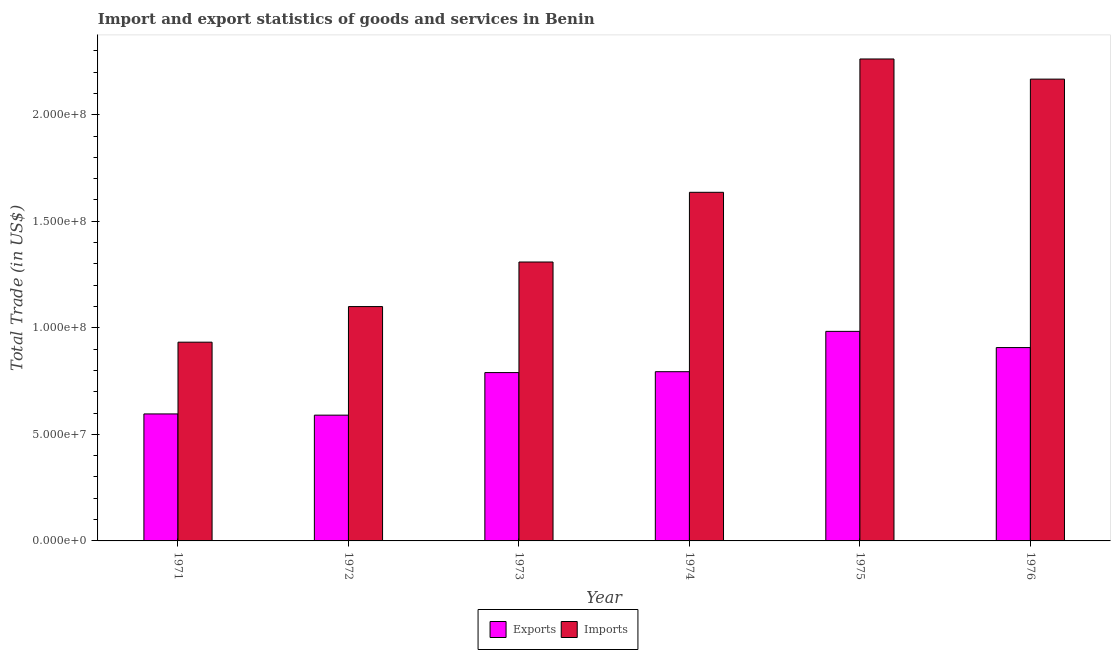How many groups of bars are there?
Your response must be concise. 6. Are the number of bars per tick equal to the number of legend labels?
Offer a terse response. Yes. Are the number of bars on each tick of the X-axis equal?
Keep it short and to the point. Yes. How many bars are there on the 6th tick from the right?
Offer a very short reply. 2. What is the label of the 6th group of bars from the left?
Your response must be concise. 1976. In how many cases, is the number of bars for a given year not equal to the number of legend labels?
Give a very brief answer. 0. What is the export of goods and services in 1974?
Your answer should be compact. 7.94e+07. Across all years, what is the maximum export of goods and services?
Give a very brief answer. 9.83e+07. Across all years, what is the minimum imports of goods and services?
Offer a very short reply. 9.33e+07. In which year was the export of goods and services maximum?
Offer a terse response. 1975. In which year was the imports of goods and services minimum?
Your answer should be compact. 1971. What is the total export of goods and services in the graph?
Your answer should be very brief. 4.66e+08. What is the difference between the imports of goods and services in 1975 and that in 1976?
Provide a succinct answer. 9.46e+06. What is the difference between the export of goods and services in 1975 and the imports of goods and services in 1974?
Give a very brief answer. 1.89e+07. What is the average imports of goods and services per year?
Provide a succinct answer. 1.57e+08. In the year 1973, what is the difference between the export of goods and services and imports of goods and services?
Give a very brief answer. 0. What is the ratio of the export of goods and services in 1971 to that in 1975?
Give a very brief answer. 0.61. Is the difference between the export of goods and services in 1972 and 1973 greater than the difference between the imports of goods and services in 1972 and 1973?
Make the answer very short. No. What is the difference between the highest and the second highest imports of goods and services?
Ensure brevity in your answer.  9.46e+06. What is the difference between the highest and the lowest imports of goods and services?
Offer a very short reply. 1.33e+08. In how many years, is the imports of goods and services greater than the average imports of goods and services taken over all years?
Offer a very short reply. 3. Is the sum of the export of goods and services in 1972 and 1975 greater than the maximum imports of goods and services across all years?
Make the answer very short. Yes. What does the 2nd bar from the left in 1971 represents?
Make the answer very short. Imports. What does the 1st bar from the right in 1976 represents?
Your answer should be very brief. Imports. What is the difference between two consecutive major ticks on the Y-axis?
Your answer should be very brief. 5.00e+07. Are the values on the major ticks of Y-axis written in scientific E-notation?
Provide a succinct answer. Yes. How are the legend labels stacked?
Keep it short and to the point. Horizontal. What is the title of the graph?
Your answer should be very brief. Import and export statistics of goods and services in Benin. Does "Formally registered" appear as one of the legend labels in the graph?
Give a very brief answer. No. What is the label or title of the Y-axis?
Make the answer very short. Total Trade (in US$). What is the Total Trade (in US$) of Exports in 1971?
Your answer should be compact. 5.96e+07. What is the Total Trade (in US$) of Imports in 1971?
Ensure brevity in your answer.  9.33e+07. What is the Total Trade (in US$) of Exports in 1972?
Ensure brevity in your answer.  5.90e+07. What is the Total Trade (in US$) in Imports in 1972?
Your response must be concise. 1.10e+08. What is the Total Trade (in US$) in Exports in 1973?
Your answer should be compact. 7.90e+07. What is the Total Trade (in US$) of Imports in 1973?
Provide a short and direct response. 1.31e+08. What is the Total Trade (in US$) of Exports in 1974?
Offer a terse response. 7.94e+07. What is the Total Trade (in US$) in Imports in 1974?
Offer a very short reply. 1.64e+08. What is the Total Trade (in US$) of Exports in 1975?
Offer a terse response. 9.83e+07. What is the Total Trade (in US$) of Imports in 1975?
Your answer should be compact. 2.26e+08. What is the Total Trade (in US$) of Exports in 1976?
Provide a succinct answer. 9.07e+07. What is the Total Trade (in US$) of Imports in 1976?
Your answer should be very brief. 2.17e+08. Across all years, what is the maximum Total Trade (in US$) in Exports?
Make the answer very short. 9.83e+07. Across all years, what is the maximum Total Trade (in US$) in Imports?
Make the answer very short. 2.26e+08. Across all years, what is the minimum Total Trade (in US$) of Exports?
Provide a short and direct response. 5.90e+07. Across all years, what is the minimum Total Trade (in US$) of Imports?
Make the answer very short. 9.33e+07. What is the total Total Trade (in US$) of Exports in the graph?
Your response must be concise. 4.66e+08. What is the total Total Trade (in US$) in Imports in the graph?
Your response must be concise. 9.41e+08. What is the difference between the Total Trade (in US$) in Exports in 1971 and that in 1972?
Your response must be concise. 5.72e+05. What is the difference between the Total Trade (in US$) of Imports in 1971 and that in 1972?
Your answer should be compact. -1.67e+07. What is the difference between the Total Trade (in US$) of Exports in 1971 and that in 1973?
Your response must be concise. -1.94e+07. What is the difference between the Total Trade (in US$) of Imports in 1971 and that in 1973?
Offer a very short reply. -3.76e+07. What is the difference between the Total Trade (in US$) in Exports in 1971 and that in 1974?
Your answer should be very brief. -1.98e+07. What is the difference between the Total Trade (in US$) in Imports in 1971 and that in 1974?
Your answer should be very brief. -7.03e+07. What is the difference between the Total Trade (in US$) of Exports in 1971 and that in 1975?
Make the answer very short. -3.87e+07. What is the difference between the Total Trade (in US$) in Imports in 1971 and that in 1975?
Provide a short and direct response. -1.33e+08. What is the difference between the Total Trade (in US$) in Exports in 1971 and that in 1976?
Provide a short and direct response. -3.11e+07. What is the difference between the Total Trade (in US$) of Imports in 1971 and that in 1976?
Your response must be concise. -1.23e+08. What is the difference between the Total Trade (in US$) in Exports in 1972 and that in 1973?
Provide a short and direct response. -2.00e+07. What is the difference between the Total Trade (in US$) of Imports in 1972 and that in 1973?
Offer a terse response. -2.09e+07. What is the difference between the Total Trade (in US$) of Exports in 1972 and that in 1974?
Offer a terse response. -2.04e+07. What is the difference between the Total Trade (in US$) in Imports in 1972 and that in 1974?
Ensure brevity in your answer.  -5.36e+07. What is the difference between the Total Trade (in US$) in Exports in 1972 and that in 1975?
Give a very brief answer. -3.93e+07. What is the difference between the Total Trade (in US$) of Imports in 1972 and that in 1975?
Ensure brevity in your answer.  -1.16e+08. What is the difference between the Total Trade (in US$) of Exports in 1972 and that in 1976?
Provide a short and direct response. -3.17e+07. What is the difference between the Total Trade (in US$) of Imports in 1972 and that in 1976?
Ensure brevity in your answer.  -1.07e+08. What is the difference between the Total Trade (in US$) in Exports in 1973 and that in 1974?
Give a very brief answer. -4.13e+05. What is the difference between the Total Trade (in US$) in Imports in 1973 and that in 1974?
Your answer should be very brief. -3.27e+07. What is the difference between the Total Trade (in US$) of Exports in 1973 and that in 1975?
Offer a terse response. -1.93e+07. What is the difference between the Total Trade (in US$) of Imports in 1973 and that in 1975?
Your answer should be very brief. -9.53e+07. What is the difference between the Total Trade (in US$) in Exports in 1973 and that in 1976?
Offer a very short reply. -1.17e+07. What is the difference between the Total Trade (in US$) in Imports in 1973 and that in 1976?
Provide a short and direct response. -8.58e+07. What is the difference between the Total Trade (in US$) of Exports in 1974 and that in 1975?
Your response must be concise. -1.89e+07. What is the difference between the Total Trade (in US$) of Imports in 1974 and that in 1975?
Ensure brevity in your answer.  -6.26e+07. What is the difference between the Total Trade (in US$) of Exports in 1974 and that in 1976?
Keep it short and to the point. -1.13e+07. What is the difference between the Total Trade (in US$) of Imports in 1974 and that in 1976?
Your answer should be compact. -5.31e+07. What is the difference between the Total Trade (in US$) in Exports in 1975 and that in 1976?
Your answer should be compact. 7.61e+06. What is the difference between the Total Trade (in US$) in Imports in 1975 and that in 1976?
Make the answer very short. 9.46e+06. What is the difference between the Total Trade (in US$) in Exports in 1971 and the Total Trade (in US$) in Imports in 1972?
Give a very brief answer. -5.04e+07. What is the difference between the Total Trade (in US$) of Exports in 1971 and the Total Trade (in US$) of Imports in 1973?
Offer a terse response. -7.13e+07. What is the difference between the Total Trade (in US$) in Exports in 1971 and the Total Trade (in US$) in Imports in 1974?
Provide a short and direct response. -1.04e+08. What is the difference between the Total Trade (in US$) in Exports in 1971 and the Total Trade (in US$) in Imports in 1975?
Make the answer very short. -1.67e+08. What is the difference between the Total Trade (in US$) in Exports in 1971 and the Total Trade (in US$) in Imports in 1976?
Give a very brief answer. -1.57e+08. What is the difference between the Total Trade (in US$) in Exports in 1972 and the Total Trade (in US$) in Imports in 1973?
Keep it short and to the point. -7.19e+07. What is the difference between the Total Trade (in US$) of Exports in 1972 and the Total Trade (in US$) of Imports in 1974?
Your answer should be very brief. -1.05e+08. What is the difference between the Total Trade (in US$) of Exports in 1972 and the Total Trade (in US$) of Imports in 1975?
Offer a terse response. -1.67e+08. What is the difference between the Total Trade (in US$) of Exports in 1972 and the Total Trade (in US$) of Imports in 1976?
Give a very brief answer. -1.58e+08. What is the difference between the Total Trade (in US$) of Exports in 1973 and the Total Trade (in US$) of Imports in 1974?
Ensure brevity in your answer.  -8.46e+07. What is the difference between the Total Trade (in US$) of Exports in 1973 and the Total Trade (in US$) of Imports in 1975?
Provide a succinct answer. -1.47e+08. What is the difference between the Total Trade (in US$) of Exports in 1973 and the Total Trade (in US$) of Imports in 1976?
Make the answer very short. -1.38e+08. What is the difference between the Total Trade (in US$) of Exports in 1974 and the Total Trade (in US$) of Imports in 1975?
Your answer should be compact. -1.47e+08. What is the difference between the Total Trade (in US$) of Exports in 1974 and the Total Trade (in US$) of Imports in 1976?
Provide a short and direct response. -1.37e+08. What is the difference between the Total Trade (in US$) of Exports in 1975 and the Total Trade (in US$) of Imports in 1976?
Your answer should be compact. -1.18e+08. What is the average Total Trade (in US$) in Exports per year?
Give a very brief answer. 7.77e+07. What is the average Total Trade (in US$) of Imports per year?
Your answer should be compact. 1.57e+08. In the year 1971, what is the difference between the Total Trade (in US$) of Exports and Total Trade (in US$) of Imports?
Give a very brief answer. -3.37e+07. In the year 1972, what is the difference between the Total Trade (in US$) in Exports and Total Trade (in US$) in Imports?
Provide a succinct answer. -5.09e+07. In the year 1973, what is the difference between the Total Trade (in US$) of Exports and Total Trade (in US$) of Imports?
Offer a very short reply. -5.19e+07. In the year 1974, what is the difference between the Total Trade (in US$) in Exports and Total Trade (in US$) in Imports?
Keep it short and to the point. -8.42e+07. In the year 1975, what is the difference between the Total Trade (in US$) in Exports and Total Trade (in US$) in Imports?
Give a very brief answer. -1.28e+08. In the year 1976, what is the difference between the Total Trade (in US$) of Exports and Total Trade (in US$) of Imports?
Your response must be concise. -1.26e+08. What is the ratio of the Total Trade (in US$) in Exports in 1971 to that in 1972?
Provide a succinct answer. 1.01. What is the ratio of the Total Trade (in US$) of Imports in 1971 to that in 1972?
Your answer should be very brief. 0.85. What is the ratio of the Total Trade (in US$) in Exports in 1971 to that in 1973?
Your answer should be compact. 0.75. What is the ratio of the Total Trade (in US$) in Imports in 1971 to that in 1973?
Provide a short and direct response. 0.71. What is the ratio of the Total Trade (in US$) of Exports in 1971 to that in 1974?
Offer a terse response. 0.75. What is the ratio of the Total Trade (in US$) of Imports in 1971 to that in 1974?
Offer a very short reply. 0.57. What is the ratio of the Total Trade (in US$) in Exports in 1971 to that in 1975?
Provide a short and direct response. 0.61. What is the ratio of the Total Trade (in US$) of Imports in 1971 to that in 1975?
Make the answer very short. 0.41. What is the ratio of the Total Trade (in US$) in Exports in 1971 to that in 1976?
Offer a terse response. 0.66. What is the ratio of the Total Trade (in US$) in Imports in 1971 to that in 1976?
Your answer should be compact. 0.43. What is the ratio of the Total Trade (in US$) in Exports in 1972 to that in 1973?
Provide a short and direct response. 0.75. What is the ratio of the Total Trade (in US$) in Imports in 1972 to that in 1973?
Provide a succinct answer. 0.84. What is the ratio of the Total Trade (in US$) in Exports in 1972 to that in 1974?
Your response must be concise. 0.74. What is the ratio of the Total Trade (in US$) in Imports in 1972 to that in 1974?
Give a very brief answer. 0.67. What is the ratio of the Total Trade (in US$) in Exports in 1972 to that in 1975?
Your response must be concise. 0.6. What is the ratio of the Total Trade (in US$) in Imports in 1972 to that in 1975?
Your answer should be very brief. 0.49. What is the ratio of the Total Trade (in US$) in Exports in 1972 to that in 1976?
Ensure brevity in your answer.  0.65. What is the ratio of the Total Trade (in US$) of Imports in 1972 to that in 1976?
Offer a very short reply. 0.51. What is the ratio of the Total Trade (in US$) in Imports in 1973 to that in 1974?
Keep it short and to the point. 0.8. What is the ratio of the Total Trade (in US$) of Exports in 1973 to that in 1975?
Your answer should be compact. 0.8. What is the ratio of the Total Trade (in US$) in Imports in 1973 to that in 1975?
Your response must be concise. 0.58. What is the ratio of the Total Trade (in US$) of Exports in 1973 to that in 1976?
Offer a very short reply. 0.87. What is the ratio of the Total Trade (in US$) of Imports in 1973 to that in 1976?
Offer a very short reply. 0.6. What is the ratio of the Total Trade (in US$) of Exports in 1974 to that in 1975?
Your answer should be compact. 0.81. What is the ratio of the Total Trade (in US$) of Imports in 1974 to that in 1975?
Keep it short and to the point. 0.72. What is the ratio of the Total Trade (in US$) of Exports in 1974 to that in 1976?
Ensure brevity in your answer.  0.88. What is the ratio of the Total Trade (in US$) in Imports in 1974 to that in 1976?
Give a very brief answer. 0.75. What is the ratio of the Total Trade (in US$) of Exports in 1975 to that in 1976?
Provide a short and direct response. 1.08. What is the ratio of the Total Trade (in US$) of Imports in 1975 to that in 1976?
Offer a very short reply. 1.04. What is the difference between the highest and the second highest Total Trade (in US$) in Exports?
Make the answer very short. 7.61e+06. What is the difference between the highest and the second highest Total Trade (in US$) in Imports?
Give a very brief answer. 9.46e+06. What is the difference between the highest and the lowest Total Trade (in US$) of Exports?
Your answer should be very brief. 3.93e+07. What is the difference between the highest and the lowest Total Trade (in US$) of Imports?
Make the answer very short. 1.33e+08. 